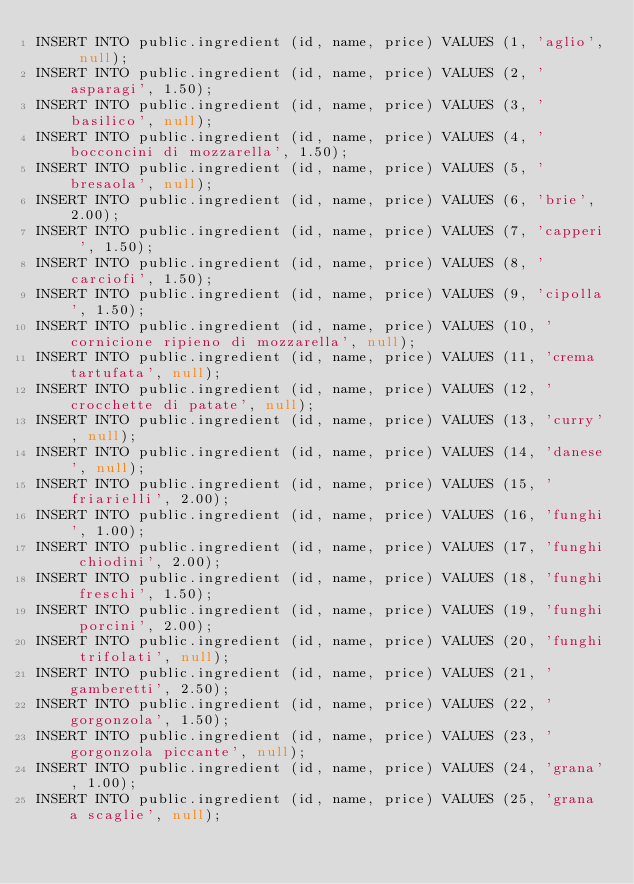Convert code to text. <code><loc_0><loc_0><loc_500><loc_500><_SQL_>INSERT INTO public.ingredient (id, name, price) VALUES (1, 'aglio', null);
INSERT INTO public.ingredient (id, name, price) VALUES (2, 'asparagi', 1.50);
INSERT INTO public.ingredient (id, name, price) VALUES (3, 'basilico', null);
INSERT INTO public.ingredient (id, name, price) VALUES (4, 'bocconcini di mozzarella', 1.50);
INSERT INTO public.ingredient (id, name, price) VALUES (5, 'bresaola', null);
INSERT INTO public.ingredient (id, name, price) VALUES (6, 'brie', 2.00);
INSERT INTO public.ingredient (id, name, price) VALUES (7, 'capperi ', 1.50);
INSERT INTO public.ingredient (id, name, price) VALUES (8, 'carciofi', 1.50);
INSERT INTO public.ingredient (id, name, price) VALUES (9, 'cipolla', 1.50);
INSERT INTO public.ingredient (id, name, price) VALUES (10, 'cornicione ripieno di mozzarella', null);
INSERT INTO public.ingredient (id, name, price) VALUES (11, 'crema tartufata', null);
INSERT INTO public.ingredient (id, name, price) VALUES (12, 'crocchette di patate', null);
INSERT INTO public.ingredient (id, name, price) VALUES (13, 'curry', null);
INSERT INTO public.ingredient (id, name, price) VALUES (14, 'danese', null);
INSERT INTO public.ingredient (id, name, price) VALUES (15, 'friarielli', 2.00);
INSERT INTO public.ingredient (id, name, price) VALUES (16, 'funghi', 1.00);
INSERT INTO public.ingredient (id, name, price) VALUES (17, 'funghi chiodini', 2.00);
INSERT INTO public.ingredient (id, name, price) VALUES (18, 'funghi freschi', 1.50);
INSERT INTO public.ingredient (id, name, price) VALUES (19, 'funghi porcini', 2.00);
INSERT INTO public.ingredient (id, name, price) VALUES (20, 'funghi trifolati', null);
INSERT INTO public.ingredient (id, name, price) VALUES (21, 'gamberetti', 2.50);
INSERT INTO public.ingredient (id, name, price) VALUES (22, 'gorgonzola', 1.50);
INSERT INTO public.ingredient (id, name, price) VALUES (23, 'gorgonzola piccante', null);
INSERT INTO public.ingredient (id, name, price) VALUES (24, 'grana', 1.00);
INSERT INTO public.ingredient (id, name, price) VALUES (25, 'grana a scaglie', null);</code> 